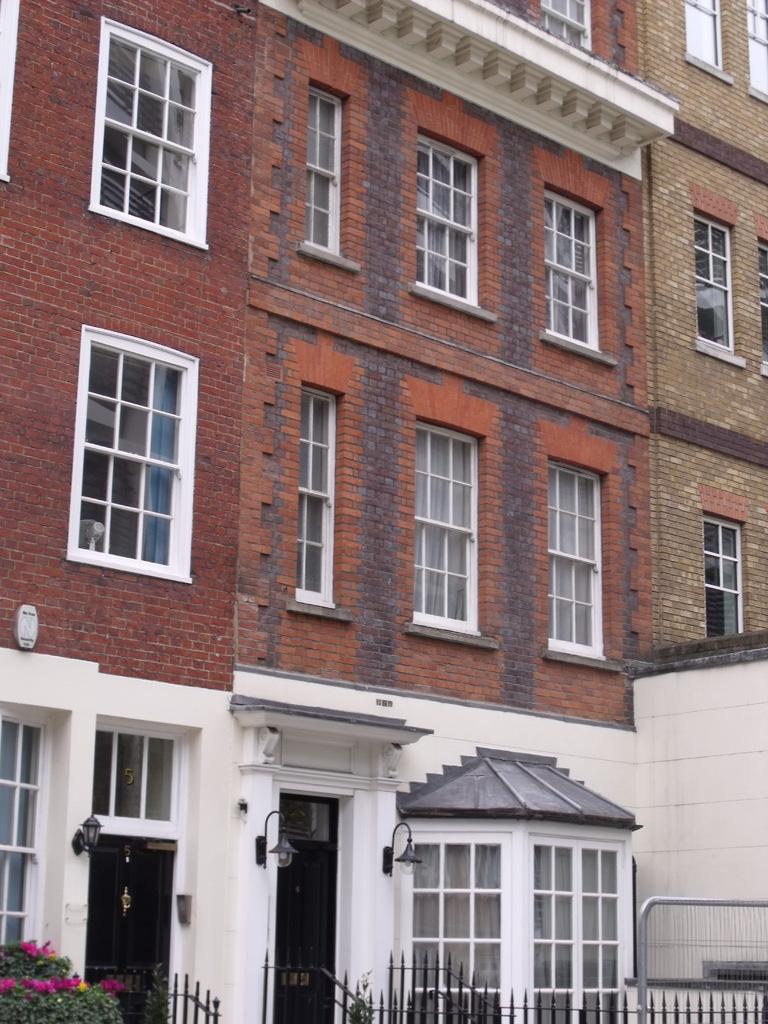What type of structures are present in the image? There are buildings in the image. What feature can be seen on the buildings? The buildings have windows. What is located in front of the buildings? There is a fence in front of the buildings. What type of vegetation is present in front of the buildings? There are plants in front of the buildings. Can you hear the shoe crying in the image? There is no shoe or crying sound present in the image. 